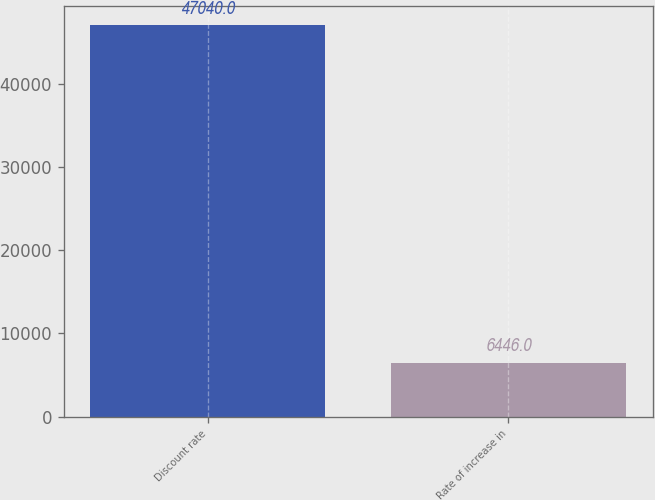<chart> <loc_0><loc_0><loc_500><loc_500><bar_chart><fcel>Discount rate<fcel>Rate of increase in<nl><fcel>47040<fcel>6446<nl></chart> 